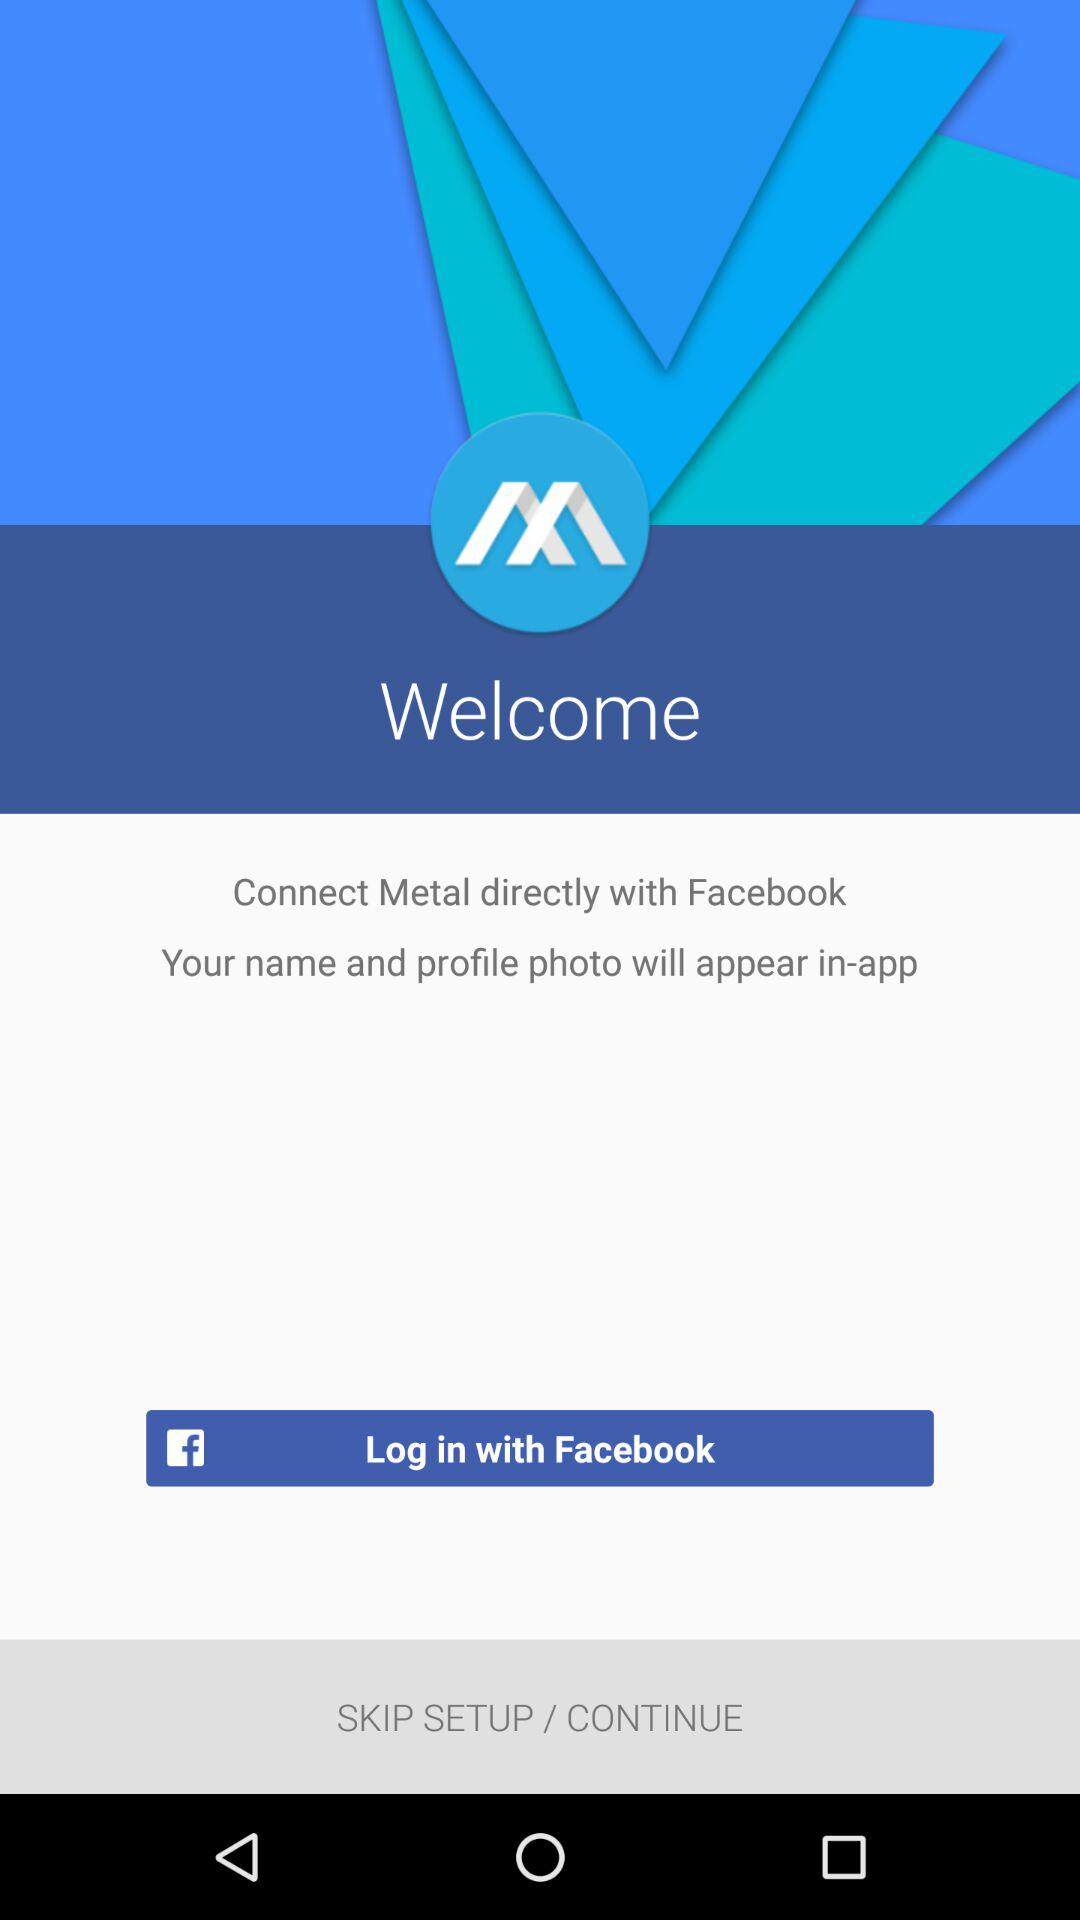What is the name of the application? The name of the application is "Metal". 